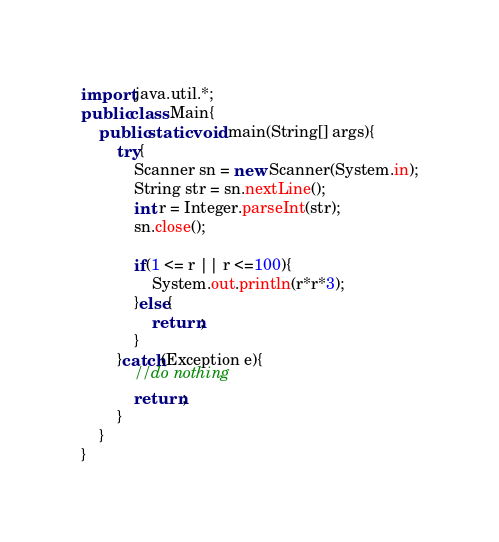<code> <loc_0><loc_0><loc_500><loc_500><_Java_>import java.util.*;
public class Main{
    public static void main(String[] args){
        try{
            Scanner sn = new Scanner(System.in);
            String str = sn.nextLine();
            int r = Integer.parseInt(str);
            sn.close();
           
            if(1 <= r || r <=100){
                System.out.println(r*r*3);
            }else{
                return;
            }
        }catch(Exception e){
            //do nothing
            return;
        }
    }
}</code> 